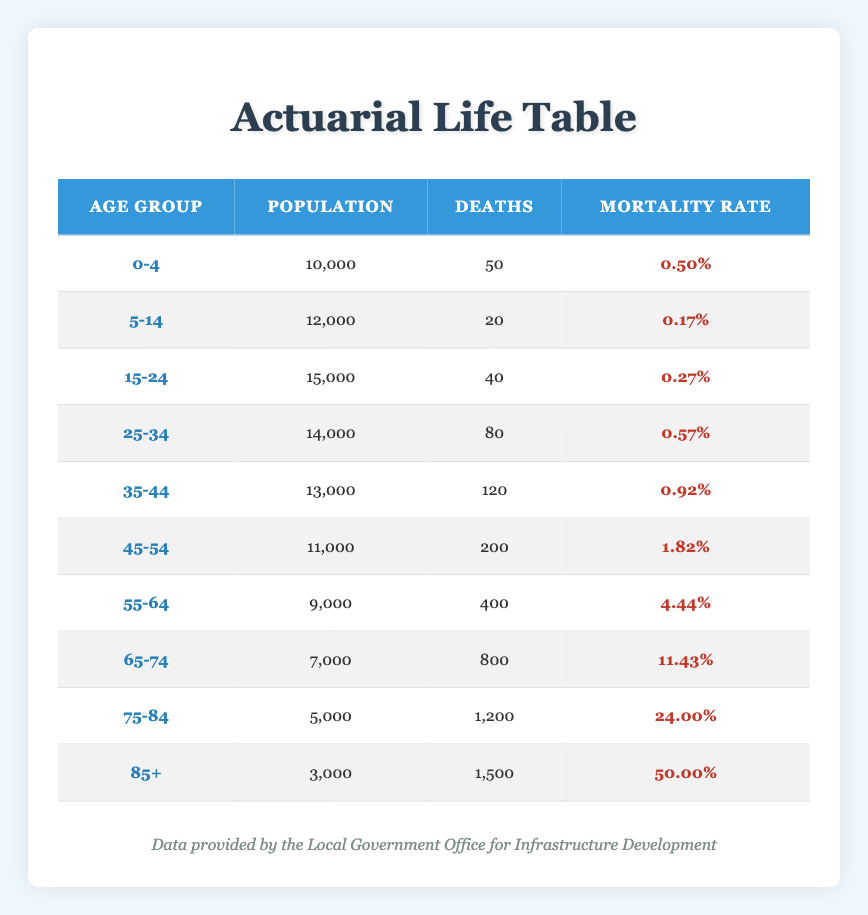What is the mortality rate for the age group 55-64? The table shows that the mortality rate for the 55-64 age group is listed directly in the relevant row, which is 0.04444.
Answer: 0.04444 How many deaths occurred in the age group 75-84? In the table, the number of deaths for the age group 75-84 is directly provided, which is 1200.
Answer: 1200 What is the total population for all age groups combined? To find the total population, add the populations from all age groups: 10000 + 12000 + 15000 + 14000 + 13000 + 11000 + 9000 + 7000 + 5000 + 3000 = 108000.
Answer: 108000 What is the mortality rate for all age groups combined? First, sum the total deaths, then divide by the total population: Total deaths = 50 + 20 + 40 + 80 + 120 + 200 + 400 + 800 + 1200 + 1500 = 3420. The mortality rate is 3420 / 108000 ≈ 0.03167.
Answer: 0.03167 Is the mortality rate for age group 65-74 greater than the mortality rate for age group 55-64? By comparing the two values from the table, the mortality rate for 65-74 is 0.11429, and for 55-64 it is 0.04444. Since 0.11429 > 0.04444, the statement is true.
Answer: Yes Which age group has the highest mortality rate? The table shows that the age group 85+ has a mortality rate of 0.5, which is the highest among all listed rates.
Answer: 85+ What is the percentage of deaths for the age group 45-54 compared to the total deaths? First, find the deaths in the 45-54 age group, which is 200. Then, calculate the total deaths, which is 3420. The percentage is (200 / 3420) * 100 ≈ 5.85%.
Answer: 5.85% Is there a significant increase in mortality rates from the age group 55-64 to 65-74? The mortality rate for 55-64 is 0.04444, and for 65-74 it is 0.11429. The difference is 0.11429 - 0.04444 = 0.06985, showing a significant increase in mortality rates.
Answer: Yes What is the average number of deaths across all age groups? To find the average, sum the total deaths (3420) and divide by the number of age groups (10): 3420 / 10 = 342.
Answer: 342 